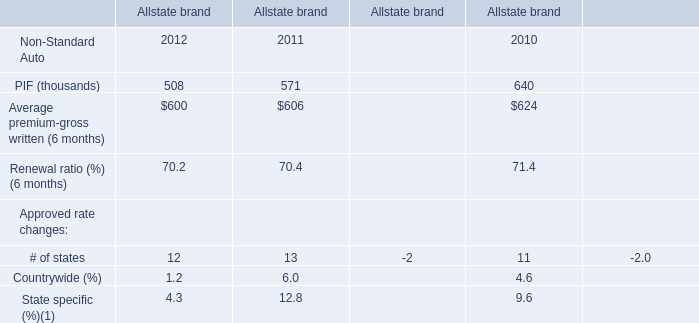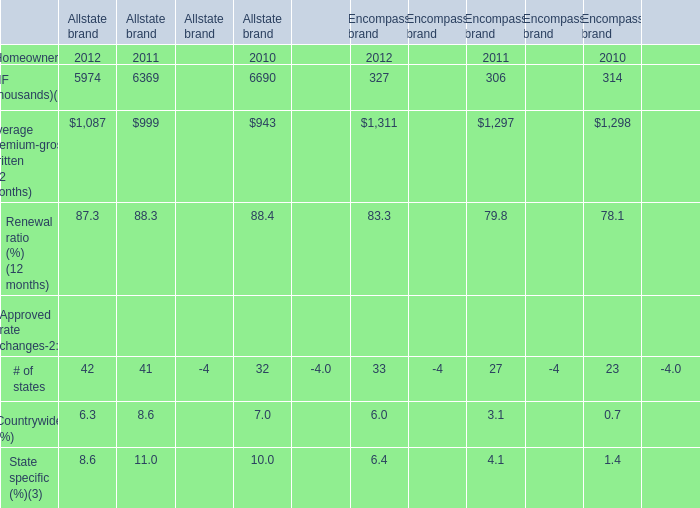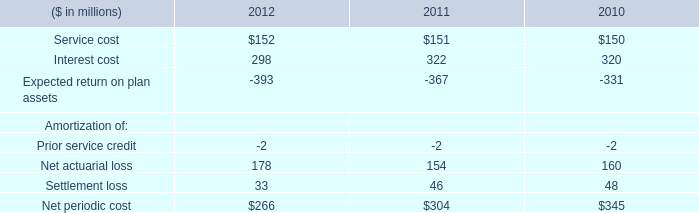What will Average premium-gross written (12 months) of Allstate brand be like in 2013 if it develops with the same increasing rate as 2012? (in thousand) 
Computations: (1087 * (1 + ((1087 - 999) / 999)))
Answer: 1182.75175. 